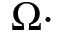<formula> <loc_0><loc_0><loc_500><loc_500>\Omega \cdot</formula> 